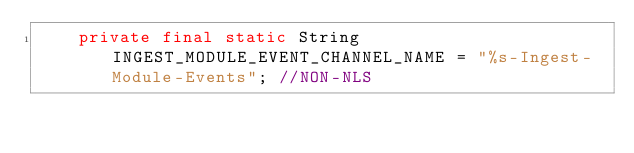<code> <loc_0><loc_0><loc_500><loc_500><_Java_>    private final static String INGEST_MODULE_EVENT_CHANNEL_NAME = "%s-Ingest-Module-Events"; //NON-NLS</code> 